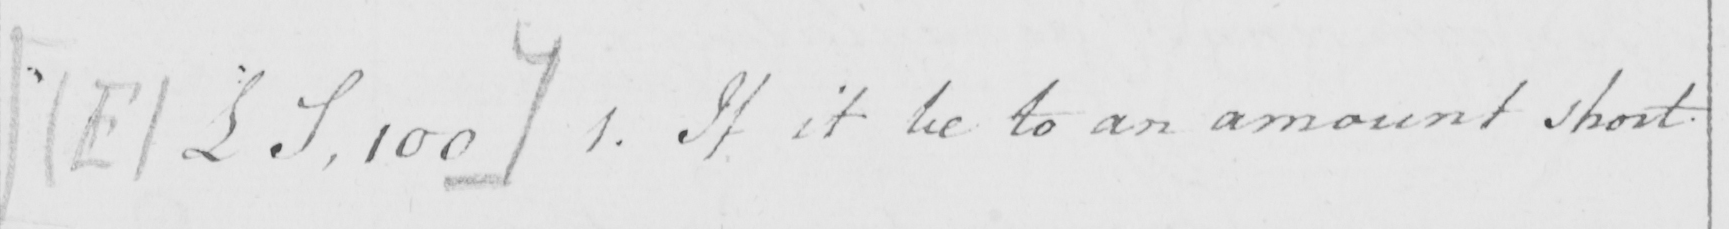What does this handwritten line say? [  ( E )  £S , 100 ]  1 . If it be to an amount short 